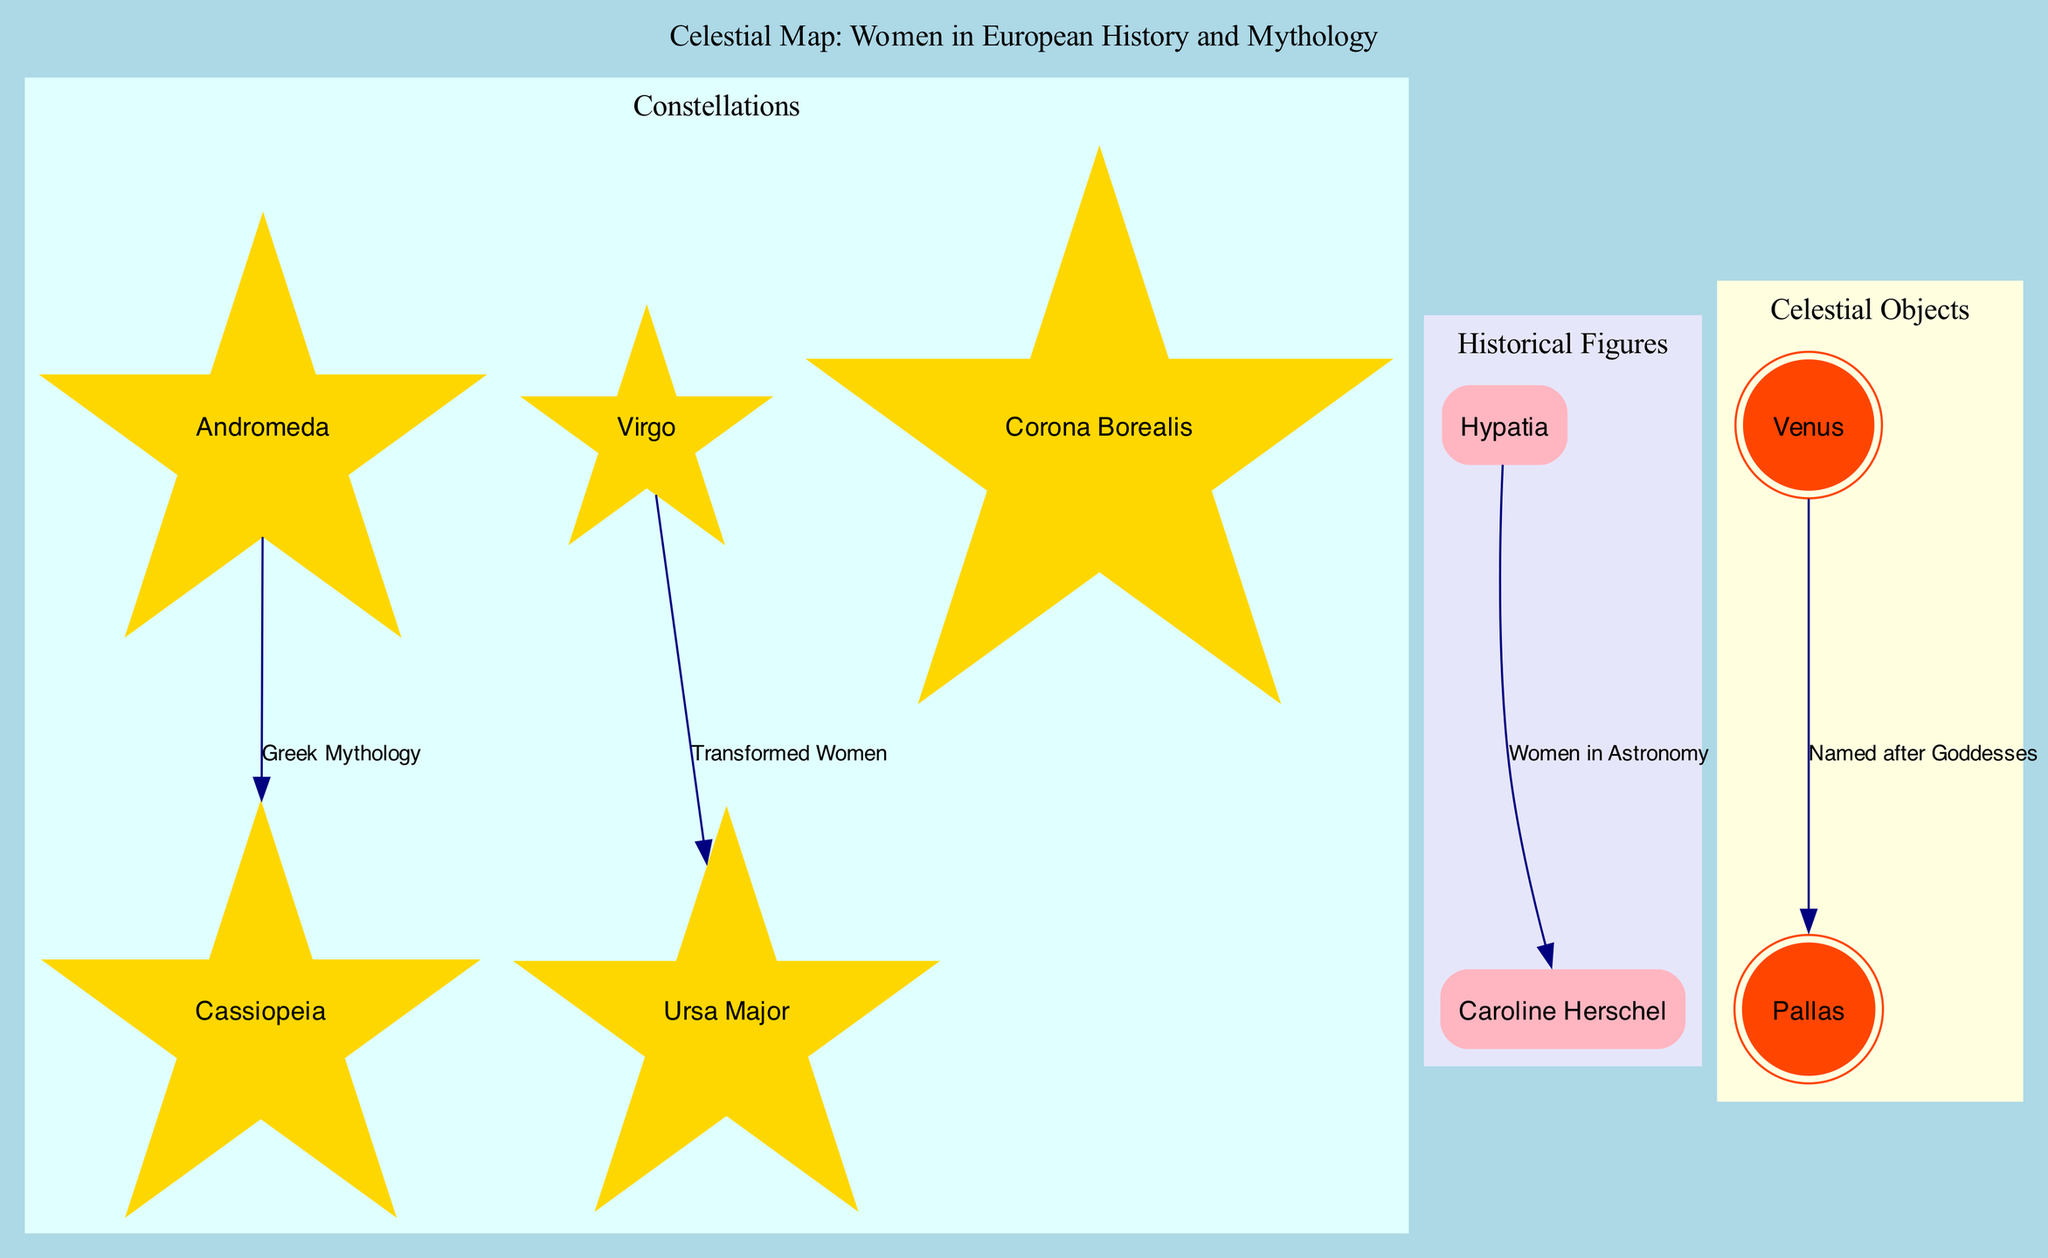What is the significance of Andromeda? The diagram indicates that Andromeda is described as a Greek princess and symbolizes female sacrifice. This information is found in the tooltip of the Andromeda node.
Answer: Greek princess, symbol of female sacrifice How many constellations are highlighted in the diagram? By counting the nodes within the "Constellations" cluster, we find five constellations: Andromeda, Cassiopeia, Virgo, Ursa Major, and Corona Borealis.
Answer: 5 Which historical figure is recognized as the first woman to discover a comet? The diagram identifies Caroline Herschel as the first woman to discover a comet. This description is provided in the tooltip associated with her node in the "Historical Figures" cluster.
Answer: Caroline Herschel What connects Hypatia and Caroline Herschel? The diagram shows an edge labeled "Women in Astronomy" that connects the nodes of Hypatia and Caroline Herschel, indicating their shared significance in the field of astronomy.
Answer: Women in Astronomy Which constellation is associated with Demeter? The diagram specifies that the constellation Virgo is associated with Demeter, goddess of agriculture. This detail can be found in the Virgo node's tooltip.
Answer: Virgo How many celestial objects are depicted in the diagram? The "Celestial Objects" cluster contains two nodes: Venus and Pallas, indicating that there are two celestial objects present in the diagram.
Answer: 2 What does Ursa Major symbolize? According to the tooltip associated with the Ursa Major node, it is linked to Callisto, a nymph transformed by Hera, which serves as its symbolic significance.
Answer: Linked to Callisto, nymph transformed by Hera What is the relationship between Venus and Pallas? The diagram presents an edge that connects Venus and Pallas with the label "Named after Goddesses," indicating their relationship through a common theme of being named after deities.
Answer: Named after Goddesses What does the constellation Cassiopeia represent? The tooltip associated with the Cassiopeia node specifies that it represents female vanity, providing a clear description of its significance.
Answer: Represents female vanity 